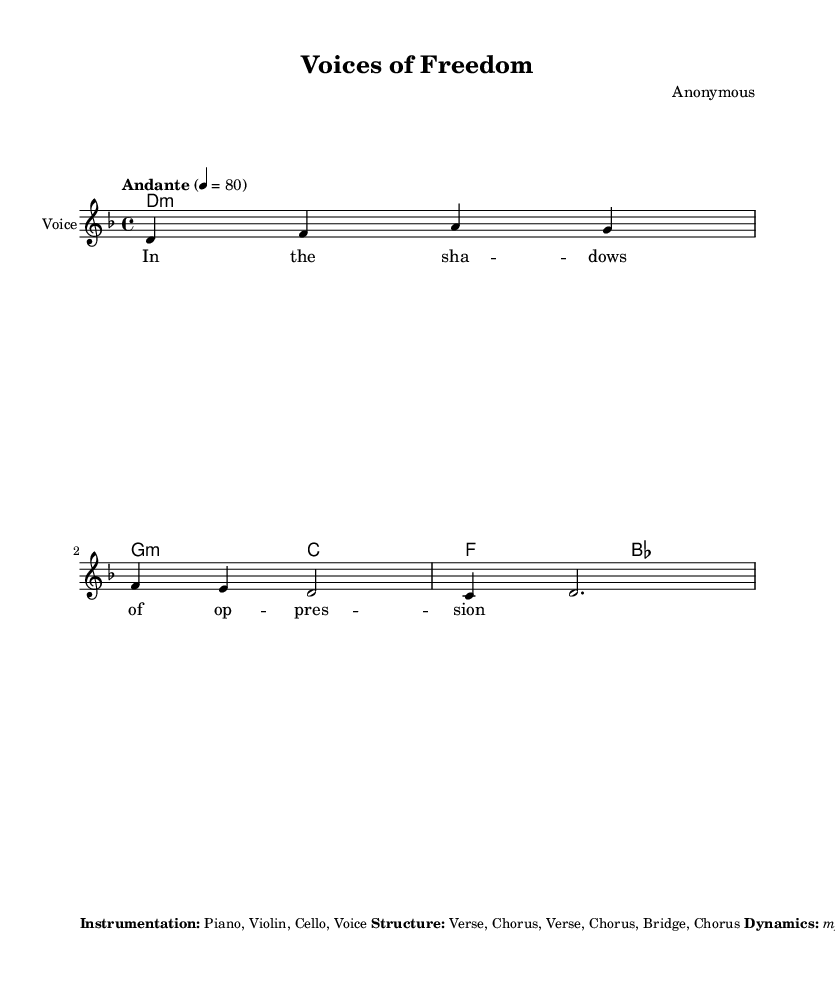What is the key signature of this music? The key signature is D minor, which has one flat (B flat). This can be identified from the key signature indicated at the beginning of the staff.
Answer: D minor What is the time signature of this piece? The time signature is 4/4, as demonstrated by the notation following the clef at the beginning of the score. This means there are four beats in a measure.
Answer: 4/4 What is the tempo marking for this song? The tempo marking is "Andante," which indicates a moderate pace. The exact tempo is specified as 4 = 80, meaning quarter note equals 80 beats per minute.
Answer: Andante How many bars are in the melody section? There are five bars in the melody section, which can be counted based on the grouping of the notes and measure lines in the melody staff.
Answer: 5 What is the harmonic structure at the beginning of the piece? The harmonic structure at the beginning consists of a D minor chord followed by a G minor and a C major chord, indicated by the chord symbols under the staff.
Answer: D minor, G minor, C major What type of dynamics are specified in this sheet music? The dynamics specified are "mp, mf, f, ff," indicating a range from mezzo-piano to fortissimo. Each dynamic is typically represented in terms of how loudly or softly the music should be played.
Answer: mp, mf, f, ff What instrument family is primarily used in this piece? The instrument family primarily used is strings and voice, as noted in the instrumentation section, which lists piano, violin, cello, and voice.
Answer: Strings and voice 